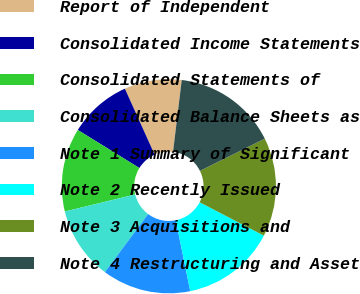Convert chart to OTSL. <chart><loc_0><loc_0><loc_500><loc_500><pie_chart><fcel>Report of Independent<fcel>Consolidated Income Statements<fcel>Consolidated Statements of<fcel>Consolidated Balance Sheets as<fcel>Note 1 Summary of Significant<fcel>Note 2 Recently Issued<fcel>Note 3 Acquisitions and<fcel>Note 4 Restructuring and Asset<nl><fcel>8.66%<fcel>9.45%<fcel>12.6%<fcel>11.02%<fcel>13.39%<fcel>14.17%<fcel>14.96%<fcel>15.75%<nl></chart> 